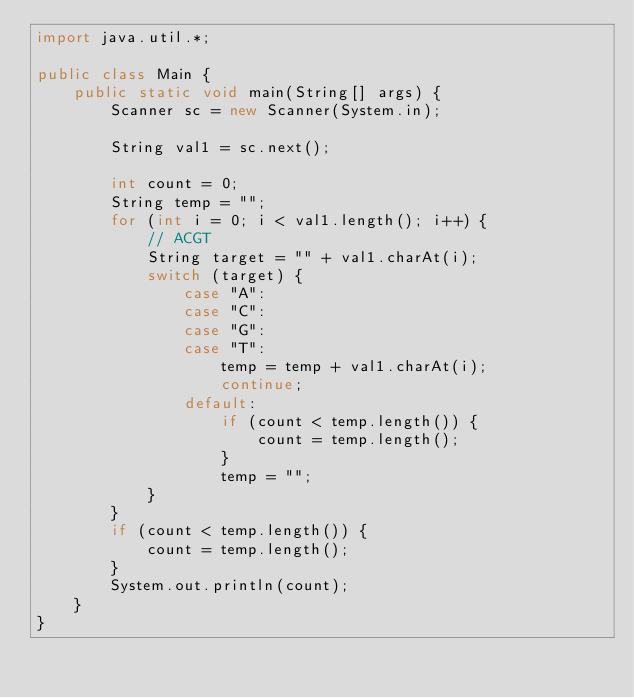<code> <loc_0><loc_0><loc_500><loc_500><_Java_>import java.util.*;

public class Main {
    public static void main(String[] args) {
        Scanner sc = new Scanner(System.in);

        String val1 = sc.next();

        int count = 0;
        String temp = "";
        for (int i = 0; i < val1.length(); i++) {
            // ACGT
            String target = "" + val1.charAt(i);
            switch (target) {
                case "A":
                case "C":
                case "G":
                case "T":
                    temp = temp + val1.charAt(i);
                    continue;
                default:
                    if (count < temp.length()) {
                        count = temp.length();
                    }
                    temp = "";
            }
        }
        if (count < temp.length()) {
            count = temp.length();
        }
        System.out.println(count);
    }
}</code> 